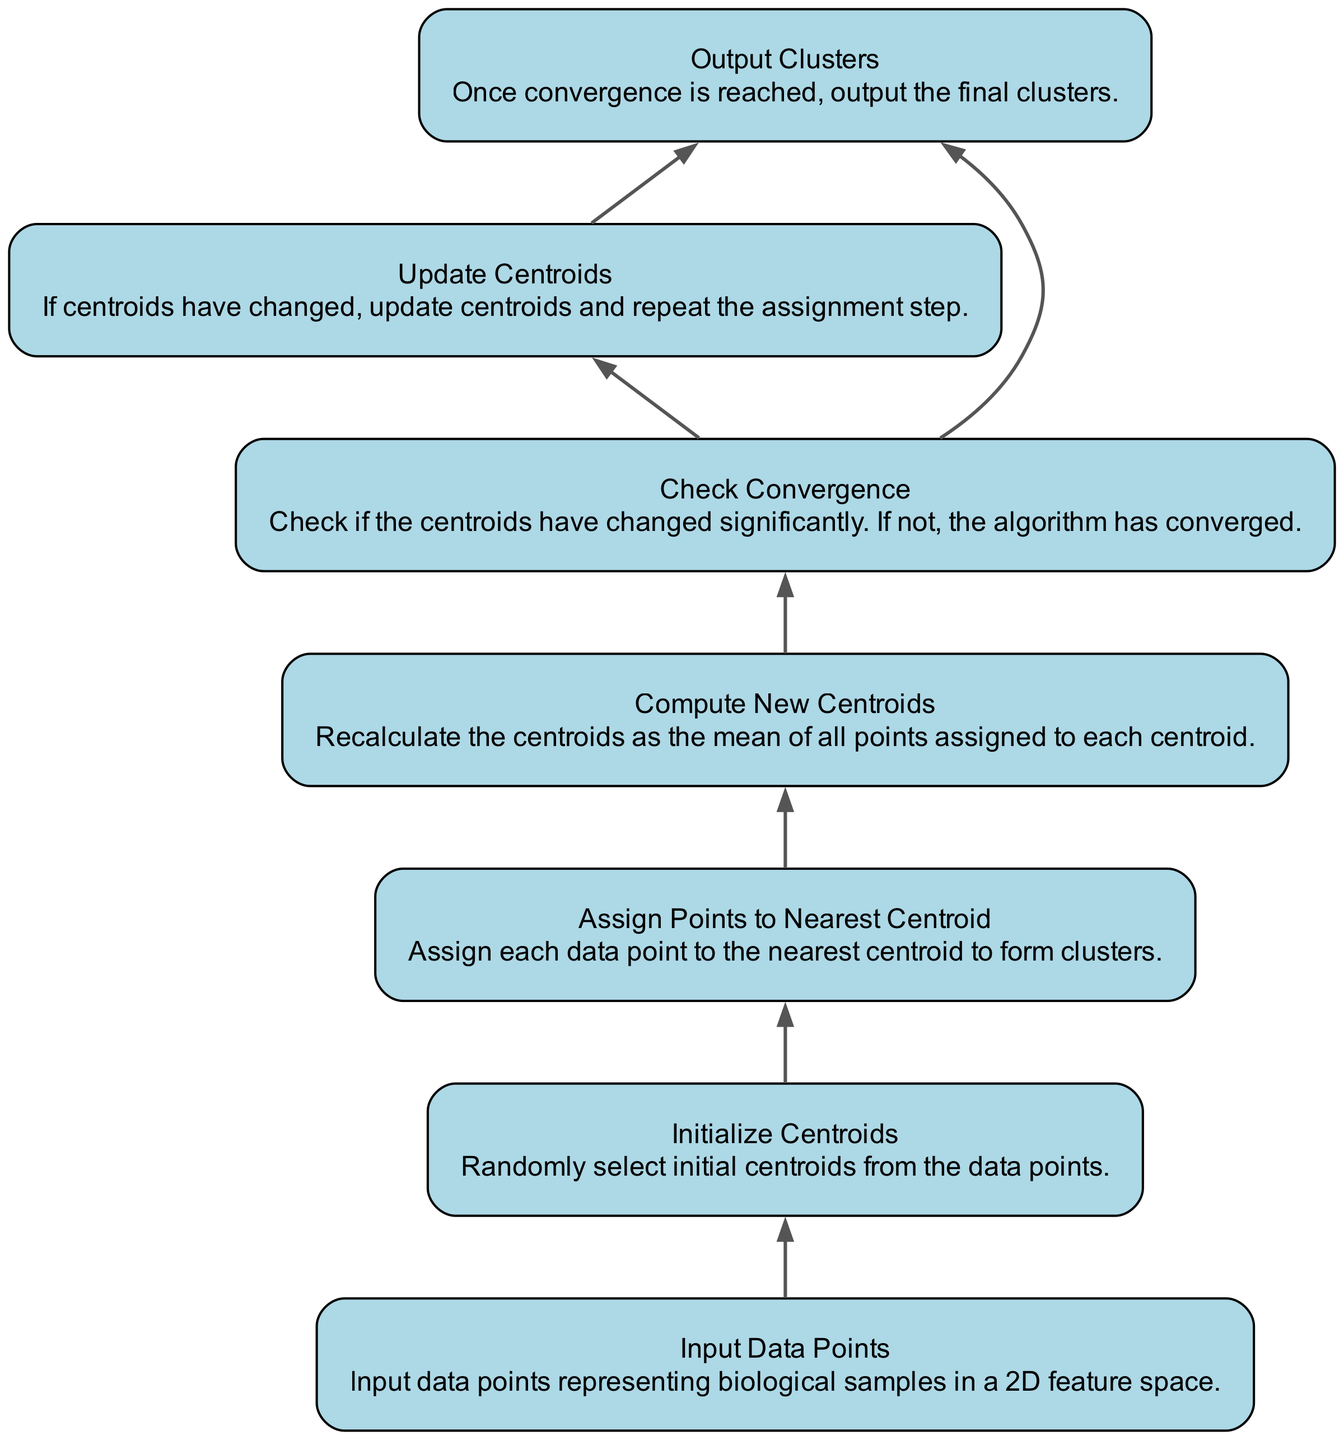What is the first step in the process? The first step in the flow chart is "Input Data Points," indicating that the initial stage involves gathering data points.
Answer: Input Data Points Which step immediately follows "Initialize Centroids"? After "Initialize Centroids," the next step in the diagram is "Assign Points to Nearest Centroid," which involves clustering the data points.
Answer: Assign Points to Nearest Centroid How many output steps are there in the diagram? The output steps are defined in the last node, "Output Clusters." There is only one output step after convergence is checked.
Answer: One What are the dependencies of "Compute New Centroids"? "Compute New Centroids" depends on the step before it, which is "Assign Points to Nearest Centroid," making it directly related to the clustering assignment.
Answer: Assign Points to Nearest Centroid What is the purpose of the "Check Convergence" step? The purpose of "Check Convergence" is to determine if the centroids have changed significantly since the last iteration; if they haven't, the clustering process is complete.
Answer: To determine centroid stability What is the last step before "Output Clusters"? The last step before "Output Clusters" is "Check Convergence," which assesses whether the algorithm should continue or stop based on the centroid changes observed.
Answer: Check Convergence If centroids have changed, what will the next step be? If the centroids have changed after checking for convergence, the next step will be "Update Centroids," which involves modifying the centroids and preparing for a new assignment of points.
Answer: Update Centroids How many nodes are directly dependent on "Check Convergence"? Two nodes are dependent on "Check Convergence": "Update Centroids" and "Output Clusters," indicating that both steps rely on the outcome of the convergence check.
Answer: Two What does this flow chart represent? This flow chart visually outlines the K-means clustering process, illustrating each step from input data to the final clustering output, specifically in a 2D space.
Answer: K-means Clustering Process 